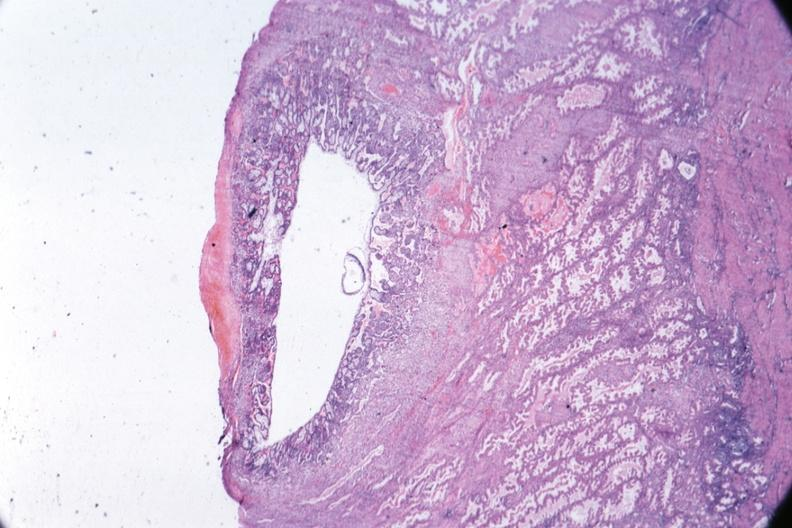what is present?
Answer the question using a single word or phrase. Female reproductive 